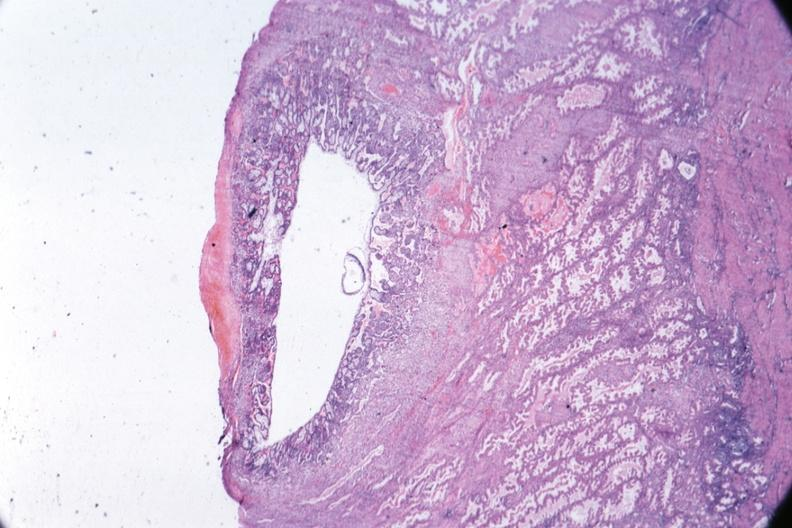what is present?
Answer the question using a single word or phrase. Female reproductive 